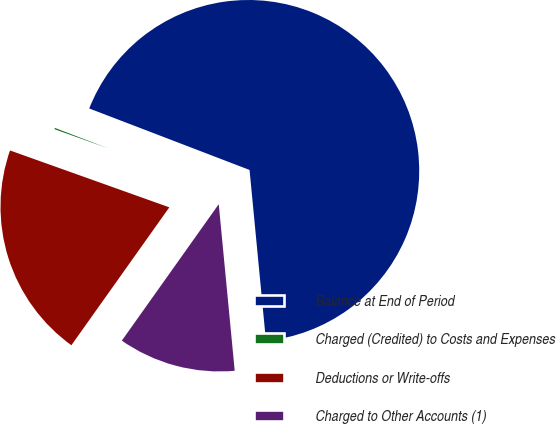<chart> <loc_0><loc_0><loc_500><loc_500><pie_chart><fcel>Balance at End of Period<fcel>Charged (Credited) to Costs and Expenses<fcel>Deductions or Write-offs<fcel>Charged to Other Accounts (1)<nl><fcel>67.65%<fcel>0.37%<fcel>20.63%<fcel>11.35%<nl></chart> 